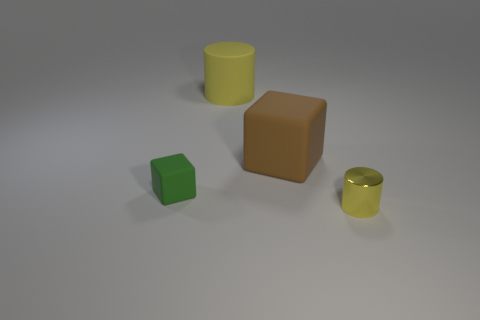Add 1 large purple matte balls. How many objects exist? 5 Subtract all cylinders. Subtract all yellow metallic cylinders. How many objects are left? 1 Add 3 small green blocks. How many small green blocks are left? 4 Add 2 big cylinders. How many big cylinders exist? 3 Subtract 0 red spheres. How many objects are left? 4 